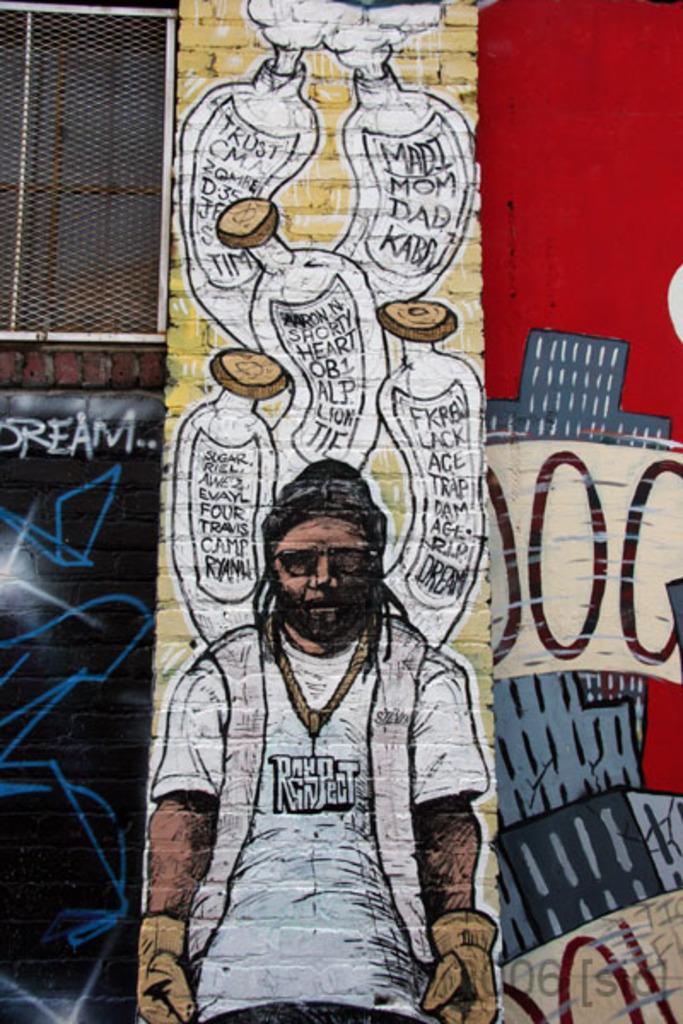How would you summarize this image in a sentence or two? In this image, we can see some paintings on the wall, on the left side top we can see a window. 